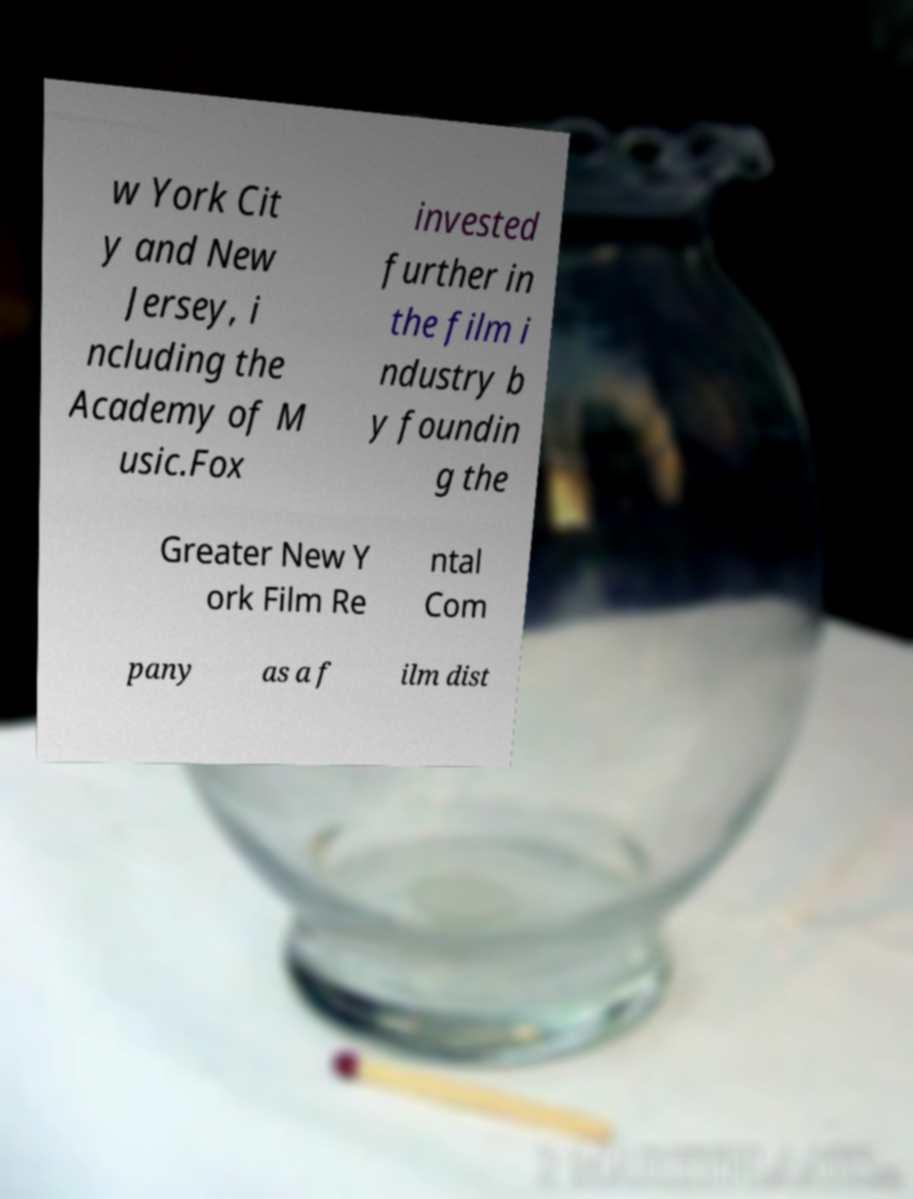What messages or text are displayed in this image? I need them in a readable, typed format. w York Cit y and New Jersey, i ncluding the Academy of M usic.Fox invested further in the film i ndustry b y foundin g the Greater New Y ork Film Re ntal Com pany as a f ilm dist 